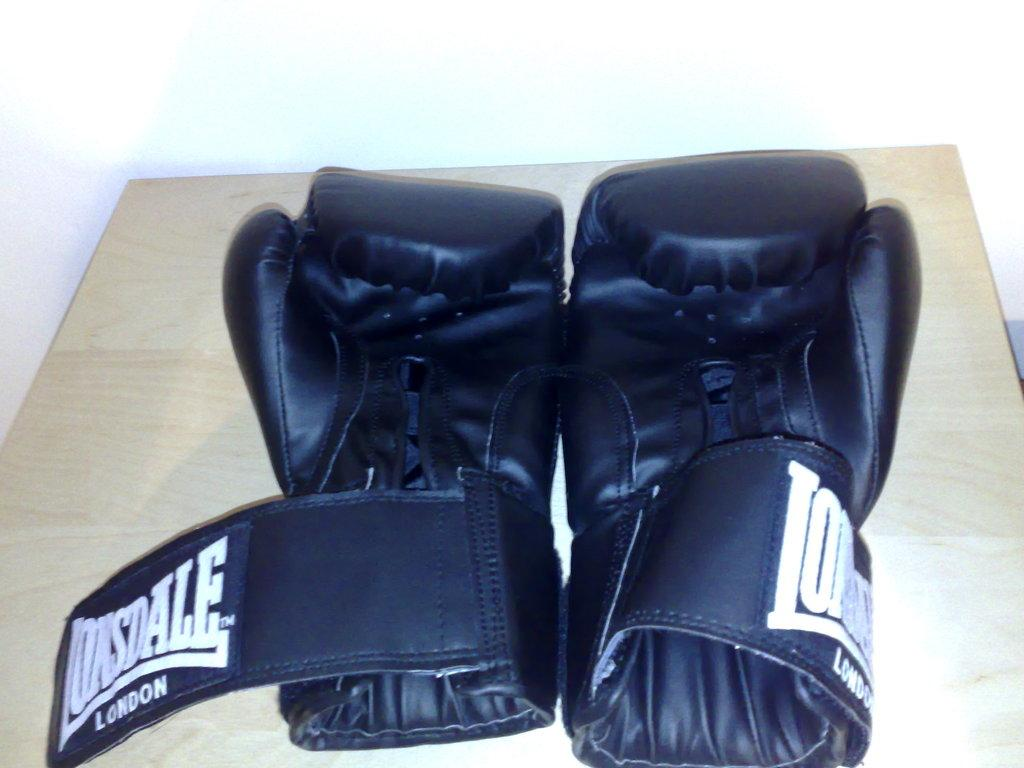What objects are in the image? There are two black gloves in the image. Where are the gloves located? The gloves are placed on a table. What type of face can be seen on the gloves in the image? There are no faces present on the gloves in the image. 